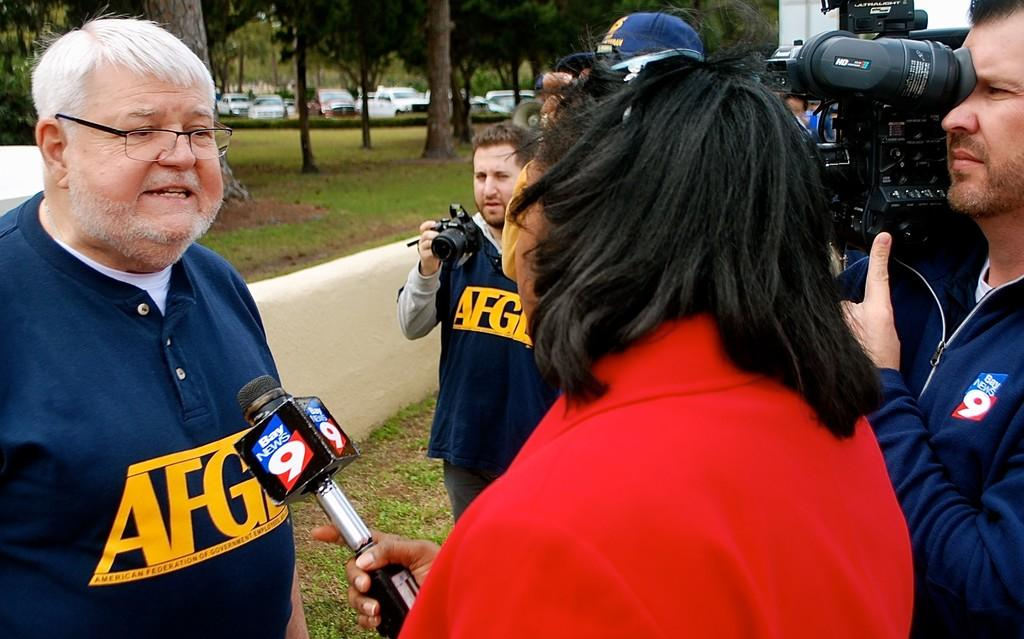How many people are in the image? There is a group of people in the image. What are two of the people holding? Two persons are holding cameras. What is the person holding that is not holding a camera? One person is holding a microphone. What type of environment is visible in the image? Grass and trees are visible in the image. What else can be seen in the image besides people and vegetation? There are vehicles in the image. What is the weight of the dust particles in the image? There is no mention of dust particles in the image, so it is not possible to determine their weight. 